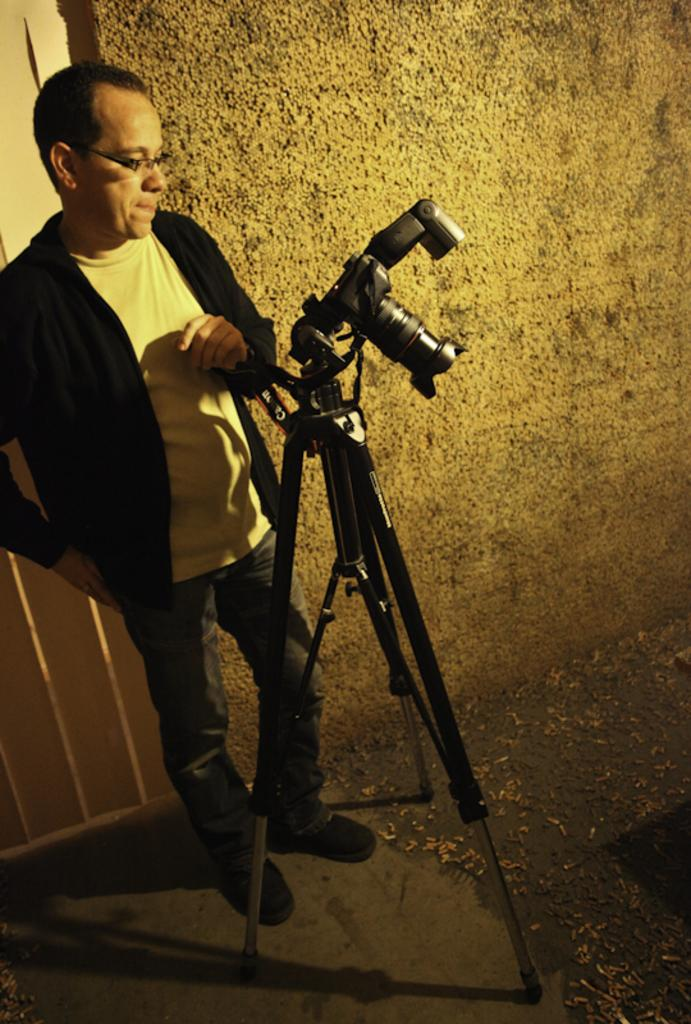What is the main subject of the image? There is a man standing in the image. Where is the man standing? The man is standing on the floor. What else can be seen in the image besides the man? There is a stand, a camera, a wall, and a curtain in the background of the image. How many bottles does the man have in his hands in the image? There are no bottles visible in the image. Is the man depicted as a slave in the image? There is no indication in the image that the man is depicted as a slave. 